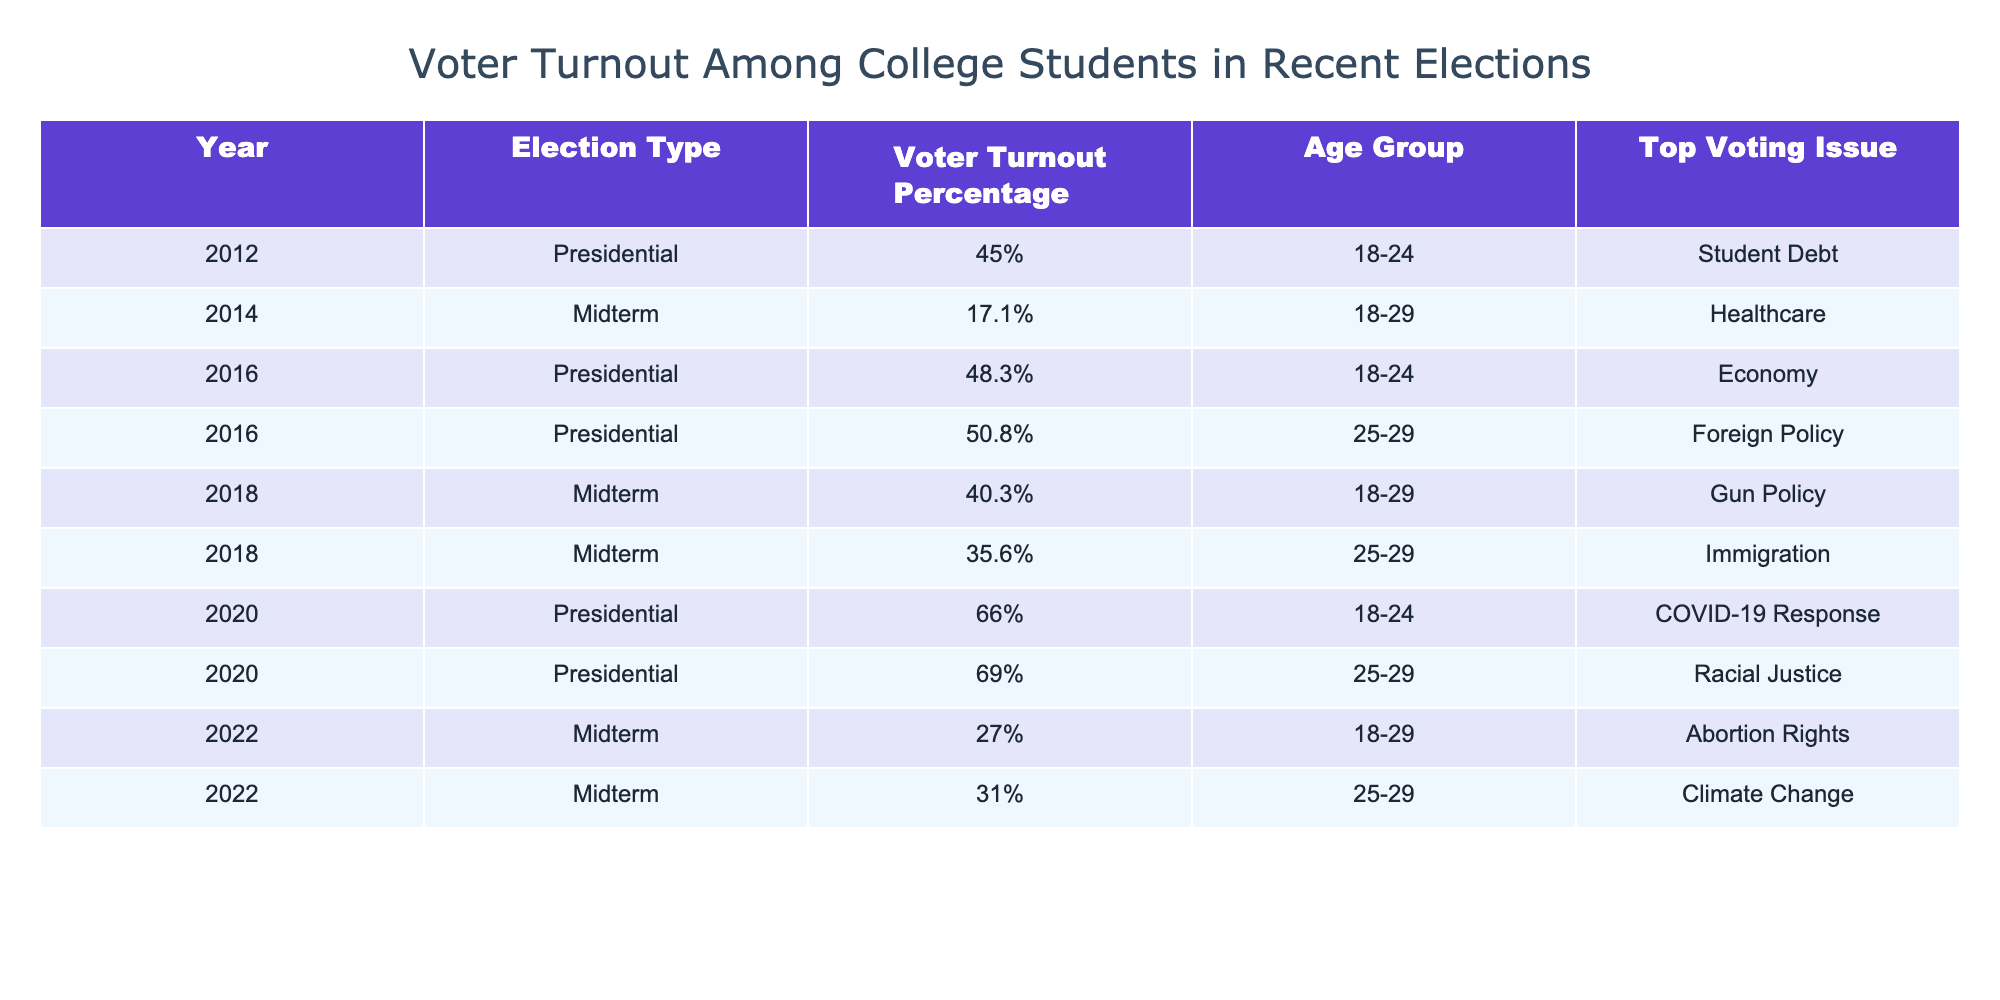What was the voter turnout percentage for college students in the 2020 Presidential election? The table shows the specific voter turnout percentage for the 2020 Presidential election under the 'Voter Turnout Percentage' column, which is 66%.
Answer: 66% Which age group had a higher voter turnout percentage in the 2016 Presidential election? The voter turnout percentage for the 18-24 age group in the 2016 Presidential election is 48.3%, while for the 25-29 age group it is 50.8%. Since 50.8% is greater than 48.3%, the 25-29 age group had a higher turnout.
Answer: 25-29 What is the average voter turnout percentage across all elections and age groups listed in the table? To find the average, sum all the voter turnout percentages: 66 + 40.3 + 48.3 + 27 + 17.1 + 45 + 69 + 35.6 + 50.8 + 31 = 429.2. There are 10 data points, so dividing gives 429.2 / 10 = 42.92%.
Answer: 42.92% In which election did the 18-29 age group have the lowest voter turnout? Reviewing the 'Voter Turnout Percentage' column for the 18-29 age group shows that the lowest turnout is 17.1% in the 2014 Midterm election.
Answer: 2014 Midterm Did the voter turnout percentage for college students increase from the 2018 Midterm election to the 2020 Presidential election? The 2018 Midterm election has a turnout of 40.3%, and the 2020 Presidential election turnout for college students is 66%. Since 66% is greater than 40.3%, the voter turnout increased.
Answer: Yes Which voting issue was the top concern for the 25-29 age group in the 2020 Presidential election? The table indicates that the top voting issue for the 25-29 age group in the 2020 Presidential election is Racial Justice.
Answer: Racial Justice What trend can be observed about the voter turnout for the 18-29 age group across the Midterm elections in 2014, 2018, and 2022? In the given data, the voter turnout percentages for the 18-29 age group in Midterm elections are 17.1% (2014), 40.3% (2018), and 27% (2022). This indicates that the turnout increased from 2014 to 2018 but decreased in 2022 compared to 2018.
Answer: Increased then decreased What was the predominant voting issue for the 18-24 age group in the 2012 Presidential election? From the table, the main voting issue for the 18-24 age group in the 2012 Presidential election is Student Debt.
Answer: Student Debt 